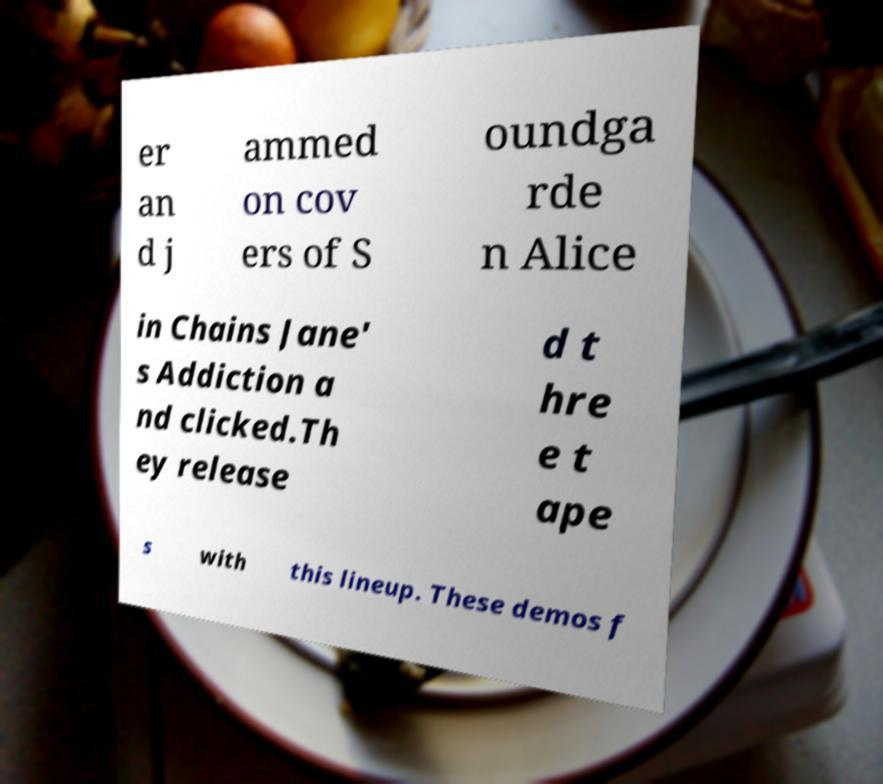What messages or text are displayed in this image? I need them in a readable, typed format. er an d j ammed on cov ers of S oundga rde n Alice in Chains Jane' s Addiction a nd clicked.Th ey release d t hre e t ape s with this lineup. These demos f 